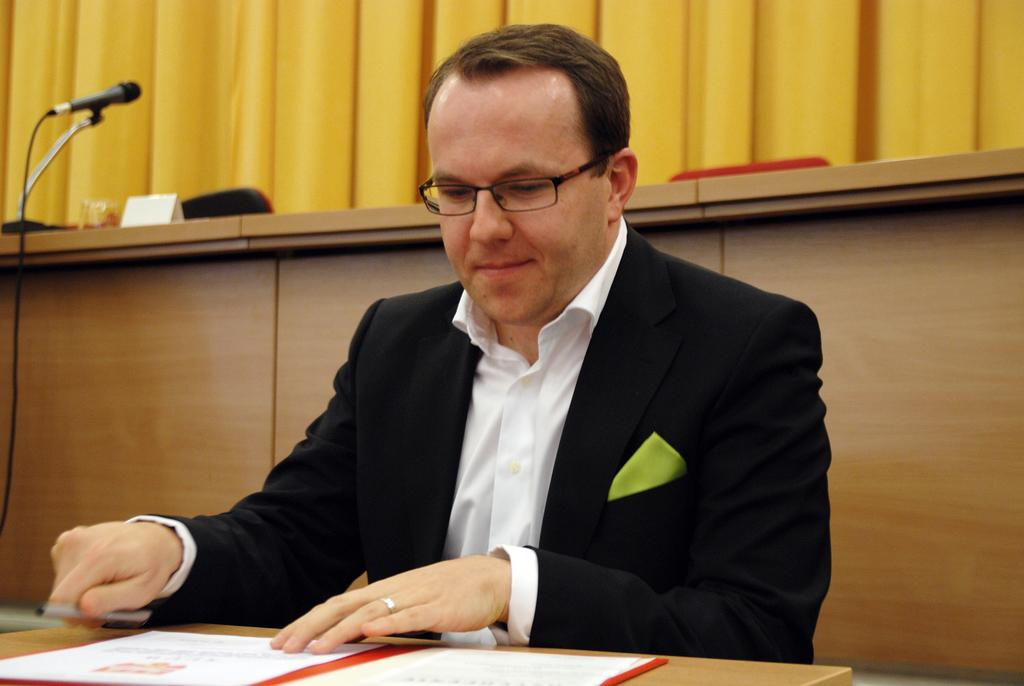What is the person in the image wearing? The person is wearing a black suit in the image. Where is the person sitting in the image? The person is sitting in front of a table in the image. What can be seen on the table in the image? There is an object and a pen on the table in the image. What type of equipment is present in the image? There is a mic in the image. What color is the curtain visible in the image? The curtain in the image is yellow. What type of quilt is being used to cover the mic in the image? There is no quilt present in the image, and the mic is not covered. 